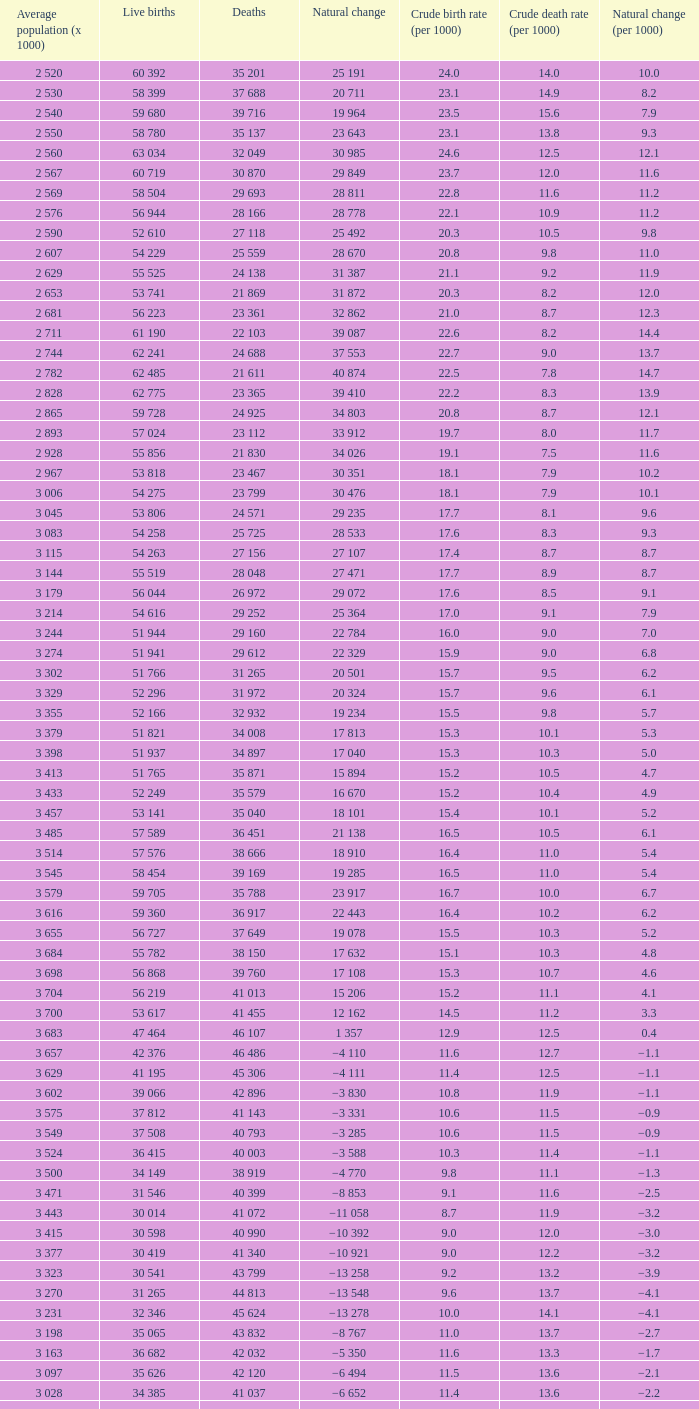Which Live births have a Natural change (per 1000) of 12.0? 53 741. 